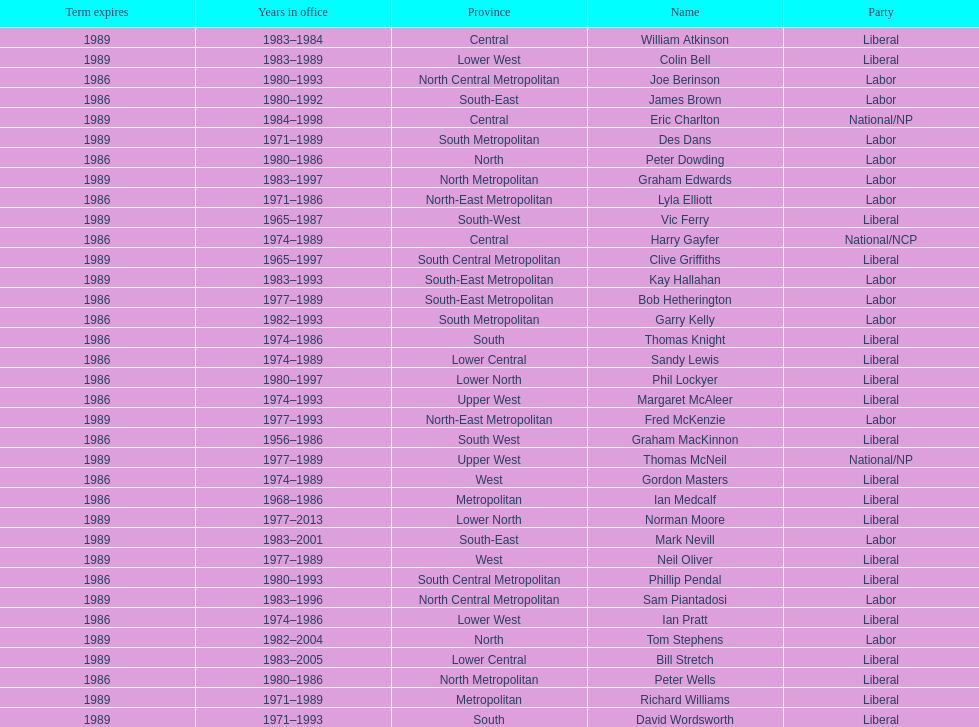Which party has the most membership? Liberal. 